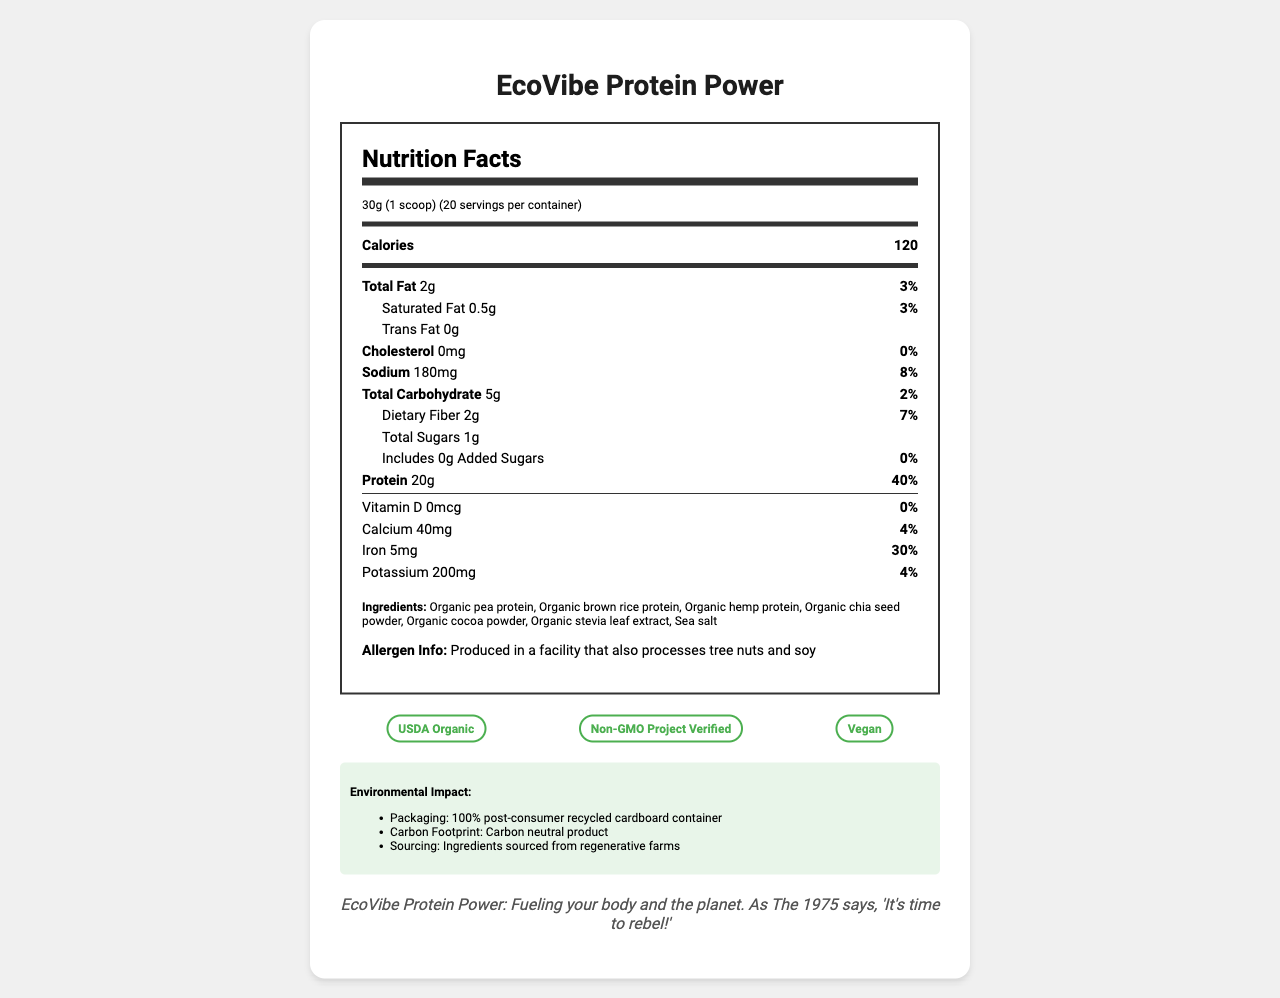what is the serving size? The serving size is stated as 30g (1 scoop) in the nutrition label under the heading "Nutrition Facts".
Answer: 30g (1 scoop) how many calories are in one serving? The document under "Calories" specifies that each serving contains 120 calories.
Answer: 120 what is the percentage of daily value for protein per serving? The nutrition label lists the daily value for protein as 40% per serving, next to the amount which is 20g.
Answer: 40% name three organic ingredients used in EcoVibe Protein Power. Three organic ingredients listed in the ingredients section are Organic pea protein, Organic brown rice protein, and Organic hemp protein.
Answer: Organic pea protein, Organic brown rice protein, Organic hemp protein how many grams of total fat are in one serving? The total fat content per serving is listed as 2g in the nutrition label.
Answer: 2g what is the daily value percentage of iron provided by one serving? 
A. 4%
B. 30%
C. 7%
D. 8% The nutrition label indicates that the iron content per serving is 5mg, which corresponds to 30% of the daily value.
Answer: B which certifications does the product have? 
I. USDA Organic
II. Gluten-Free
III. Non-GMO Project Verified
IV. Vegan The document specifies that the product is USDA Organic, Non-GMO Project Verified, and Vegan. It does not mention Gluten-Free.
Answer: I, III, IV does the product contain any added sugars? The nutrition label indicates that the product contains 0g of added sugars, which equates to 0% of the daily value.
Answer: No are tree nuts and soy processed in the same facility as this product? The allergen information section states that the product is produced in a facility that also processes tree nuts and soy.
Answer: Yes summarize the main idea of the document. The document primarily serves to inform potential consumers about the nutritional content, ingredients, and various certifications of the EcoVibe Protein Power product. It shows the product's focus on sustainability, transparency, and health-conscious features.
Answer: The document provides detailed nutritional information about EcoVibe Protein Power, a plant-based protein powder. It highlights its organic ingredients, environmentally conscious packaging, and certifications like USDA Organic, Non-GMO, and Vegan. The document also mentions that the product is produced in a facility that processes tree nuts and soy, and states the brand’s commitment to sustainability. how much dietary fiber does each serving contain? The nutrition label specifies that each serving contains 2g of dietary fiber, which is 7% of the daily value.
Answer: 2g is the product suitable for someone allergic to milk? The document provides allergen information related only to tree nuts and soy, without mentioning milk.
Answer: Cannot be determined how many servings are there per container? The document states that there are 20 servings per container under the serving size information.
Answer: 20 servings 